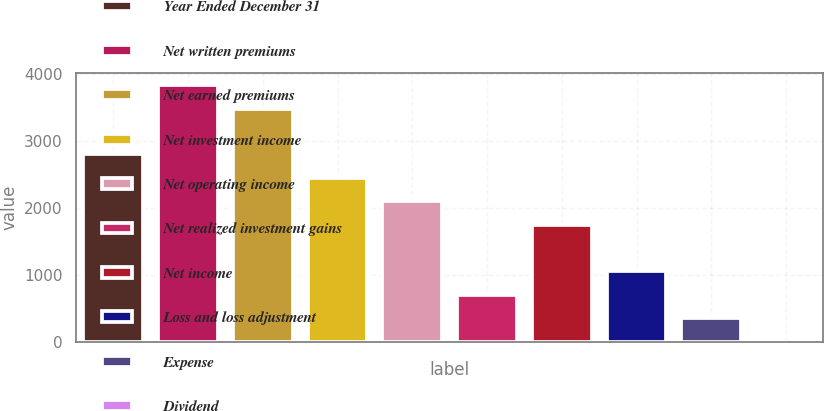Convert chart to OTSL. <chart><loc_0><loc_0><loc_500><loc_500><bar_chart><fcel>Year Ended December 31<fcel>Net written premiums<fcel>Net earned premiums<fcel>Net investment income<fcel>Net operating income<fcel>Net realized investment gains<fcel>Net income<fcel>Loss and loss adjustment<fcel>Expense<fcel>Dividend<nl><fcel>2804.84<fcel>3834.58<fcel>3484<fcel>2454.26<fcel>2103.68<fcel>701.36<fcel>1753.1<fcel>1051.94<fcel>350.78<fcel>0.2<nl></chart> 